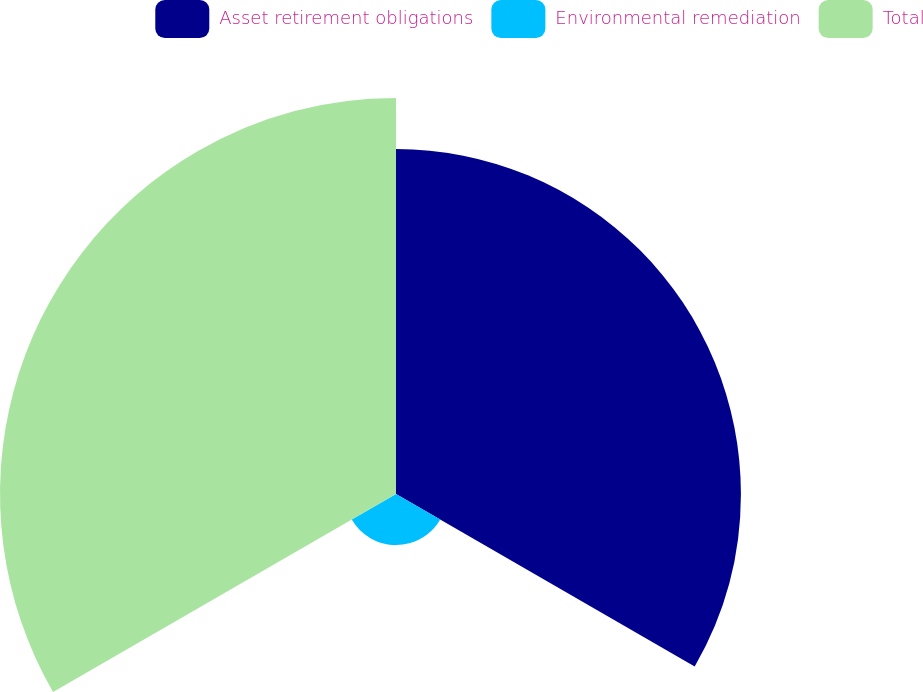Convert chart to OTSL. <chart><loc_0><loc_0><loc_500><loc_500><pie_chart><fcel>Asset retirement obligations<fcel>Environmental remediation<fcel>Total<nl><fcel>43.55%<fcel>6.45%<fcel>50.0%<nl></chart> 